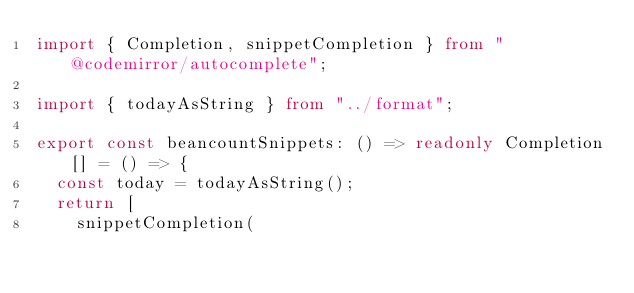Convert code to text. <code><loc_0><loc_0><loc_500><loc_500><_TypeScript_>import { Completion, snippetCompletion } from "@codemirror/autocomplete";

import { todayAsString } from "../format";

export const beancountSnippets: () => readonly Completion[] = () => {
  const today = todayAsString();
  return [
    snippetCompletion(</code> 